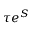Convert formula to latex. <formula><loc_0><loc_0><loc_500><loc_500>\tau e ^ { S }</formula> 